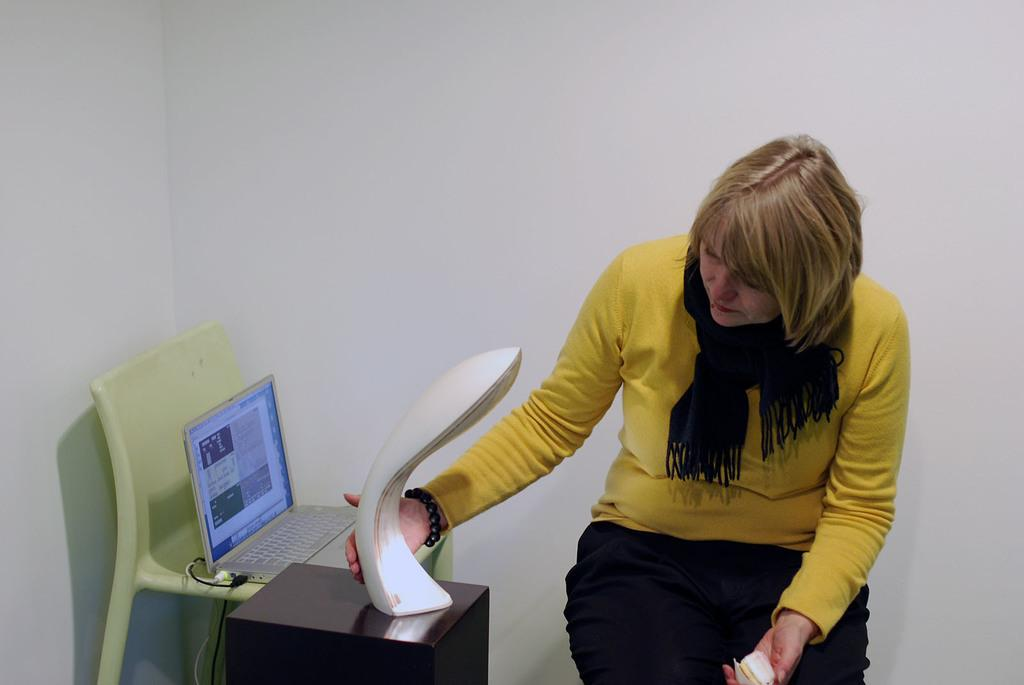What is the main subject of the image? There is a person in the image. What is the lady in the image doing? A lady is holding objects in the image. Can you describe the position of the laptop in the image? There is a laptop on a chair in the image. What is the arrangement of the objects in the image? There is an object placed on another object in the image. What type of tree can be seen in the image? There is no tree present in the image. What is the topic of the discussion taking place in the image? There is no discussion taking place in the image. 